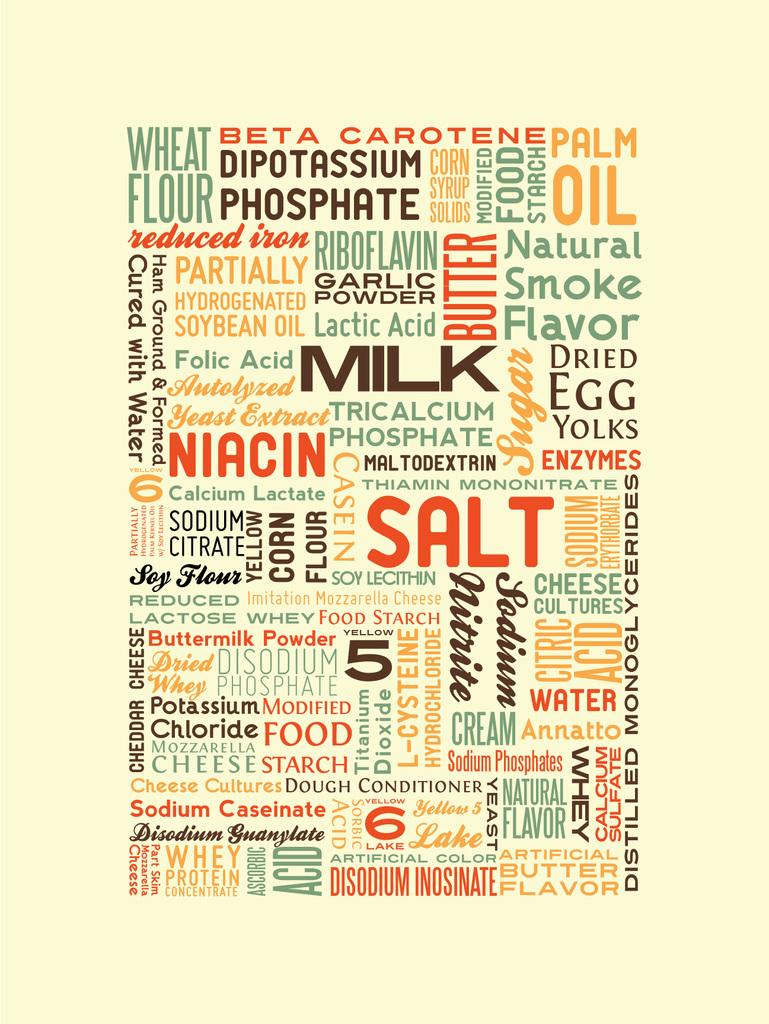<image>
Render a clear and concise summary of the photo. A graphic displays food related words, such as milk, salt and cream. 